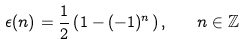Convert formula to latex. <formula><loc_0><loc_0><loc_500><loc_500>\epsilon ( n ) = \frac { 1 } { 2 } \left ( 1 - ( - 1 ) ^ { n } \right ) , \quad n \in \mathbb { Z }</formula> 